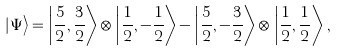Convert formula to latex. <formula><loc_0><loc_0><loc_500><loc_500>\left | \Psi \right \rangle = \left | \frac { 5 } { 2 } , \frac { 3 } { 2 } \right \rangle \otimes \left | \frac { 1 } { 2 } , - \frac { 1 } { 2 } \right \rangle - \left | \frac { 5 } { 2 } , - \frac { 3 } { 2 } \right \rangle \otimes \left | \frac { 1 } { 2 } , \frac { 1 } { 2 } \right \rangle \, ,</formula> 